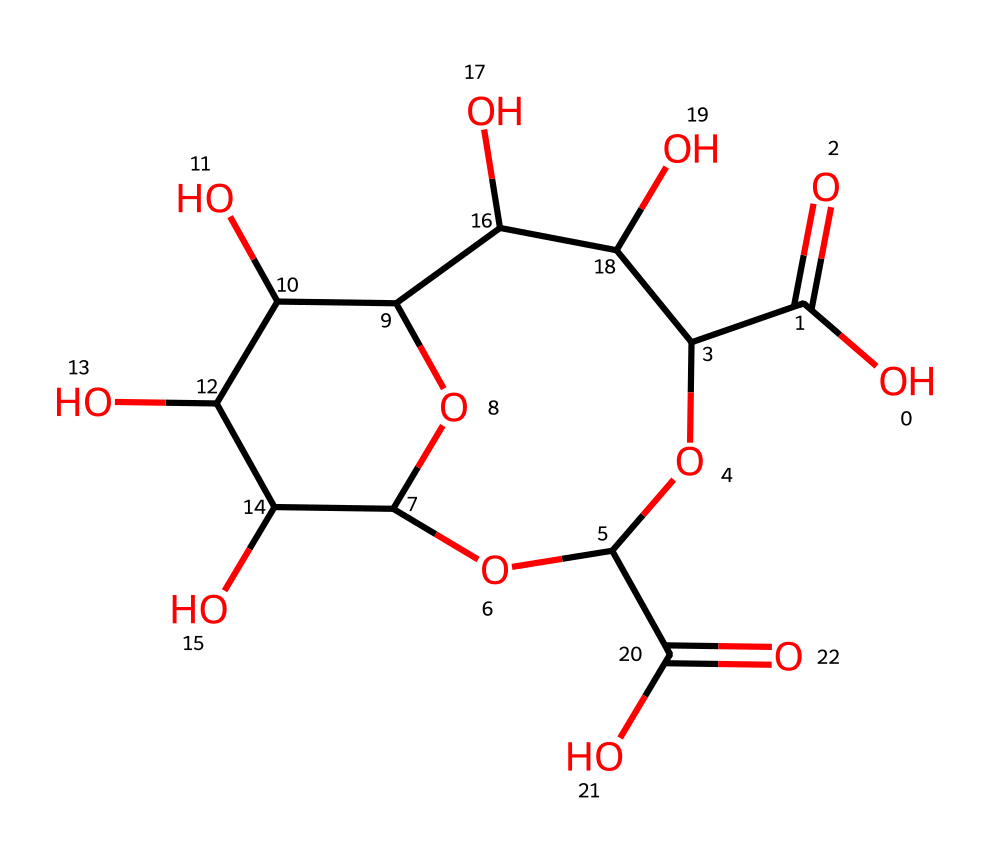What is the molecular formula of this compound? By analyzing the SMILES representation, we can extract the atoms present: carbon (C), hydrogen (H), and oxygen (O). Counting them, we find there are 12 carbons, 20 hydrogens, and 10 oxygens. Therefore, the molecular formula is C12H20O10.
Answer: C12H20O10 How many rings are present in this structure? The SMILES indicates the presence of two "C" in the sequence with "OC" preceding them; this suggests there are two cyclic structures. Visual inspection of the chemical structure reveals two rings formed by the cyclic ethers.
Answer: 2 What type of hydrocolloid is indicated by this chemical structure? The presence of multiple hydroxyl (-OH) groups and the carboxylic acid groups (evidenced by "C(=O)O" in the SMILES) suggests that this compound functions as a polysaccharide hydrocolloid, especially commonly seen in natural gums and thickeners.
Answer: polysaccharide What functional groups are present in this compound? The analysis shows the presence of carboxylic acid groups (C(=O)O) and hydroxyl groups (–OH) from the structure, indicating the multifunctional nature of this chemical, which helps in its properties as a thickener and stabilizer.
Answer: carboxylic acid and hydroxyl groups How might this compound behave in a solution? Given that it contains multiple hydroxyl and carboxyl functional groups, this hydrocolloid is likely to enhance viscosity and exhibit non-Newtonian fluid properties, meaning it can change its viscosity under shear stress. These attributes are crucial for applications in food and pharmaceuticals.
Answer: non-Newtonian fluid 